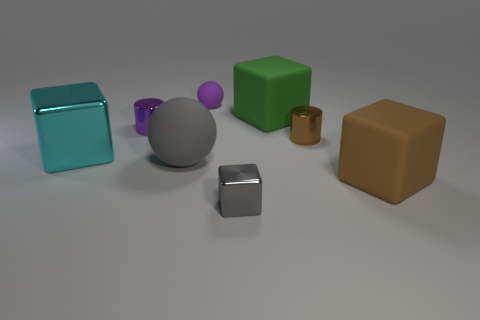What number of things have the same color as the small cube?
Your answer should be very brief. 1. What shape is the gray thing that is the same size as the purple metallic cylinder?
Keep it short and to the point. Cube. There is a big green thing; are there any big gray matte balls to the right of it?
Keep it short and to the point. No. Do the gray matte sphere and the gray block have the same size?
Your answer should be very brief. No. There is a big rubber thing on the right side of the green thing; what shape is it?
Offer a terse response. Cube. Is there a green matte thing that has the same size as the cyan block?
Provide a succinct answer. Yes. There is a cyan object that is the same size as the brown cube; what is it made of?
Make the answer very short. Metal. What size is the metal cylinder to the right of the small purple rubber thing?
Ensure brevity in your answer.  Small. What size is the gray block?
Your answer should be compact. Small. Does the purple shiny object have the same size as the brown metal object right of the gray matte thing?
Offer a very short reply. Yes. 